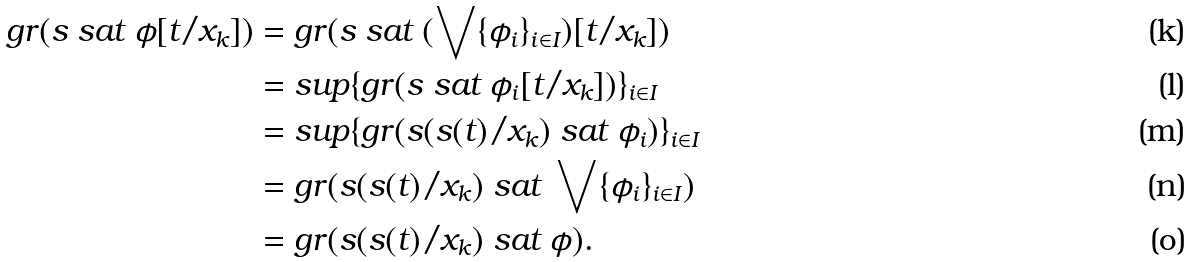Convert formula to latex. <formula><loc_0><loc_0><loc_500><loc_500>g r ( s \ \text {sat} \ \phi [ t / x _ { k } ] ) & = g r ( s \ \text {sat} \ ( \bigvee \{ \phi _ { i } \} _ { i \in I } ) [ t / x _ { k } ] ) \\ & = s u p \{ g r ( s \ \text {sat} \ \phi _ { i } [ t / x _ { k } ] ) \} _ { i \in I } \\ & = s u p \{ g r ( s ( s ( t ) / x _ { k } ) \ \text {sat} \ \phi _ { i } ) \} _ { i \in I } \\ & = g r ( s ( s ( t ) / x _ { k } ) \ \text {sat} \ \bigvee \{ \phi _ { i } \} _ { i \in I } ) \\ & = g r ( s ( s ( t ) / x _ { k } ) \ \text {sat} \ \phi ) .</formula> 